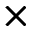Convert formula to latex. <formula><loc_0><loc_0><loc_500><loc_500>\times</formula> 